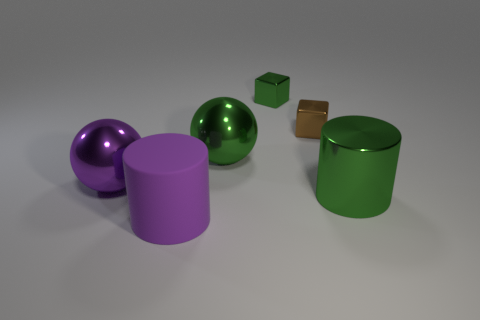There is a cylinder that is to the right of the small green metallic object that is to the right of the matte cylinder; what is its color?
Your answer should be compact. Green. The purple ball that is made of the same material as the green cube is what size?
Keep it short and to the point. Large. What number of tiny green things are the same shape as the tiny brown metallic object?
Offer a very short reply. 1. What number of objects are green cylinders on the right side of the big purple metallic ball or metallic things that are on the right side of the purple matte thing?
Ensure brevity in your answer.  4. There is a large green object to the left of the green cube; what number of tiny objects are on the left side of it?
Your answer should be very brief. 0. Does the metal thing that is to the right of the brown metal cube have the same shape as the large shiny thing behind the big purple sphere?
Keep it short and to the point. No. What is the shape of the small metallic thing that is the same color as the large metal cylinder?
Keep it short and to the point. Cube. Are there any big purple balls that have the same material as the large green ball?
Ensure brevity in your answer.  Yes. What number of shiny things are blue cylinders or big purple spheres?
Your response must be concise. 1. What shape is the purple object in front of the large object that is right of the green ball?
Your answer should be compact. Cylinder. 